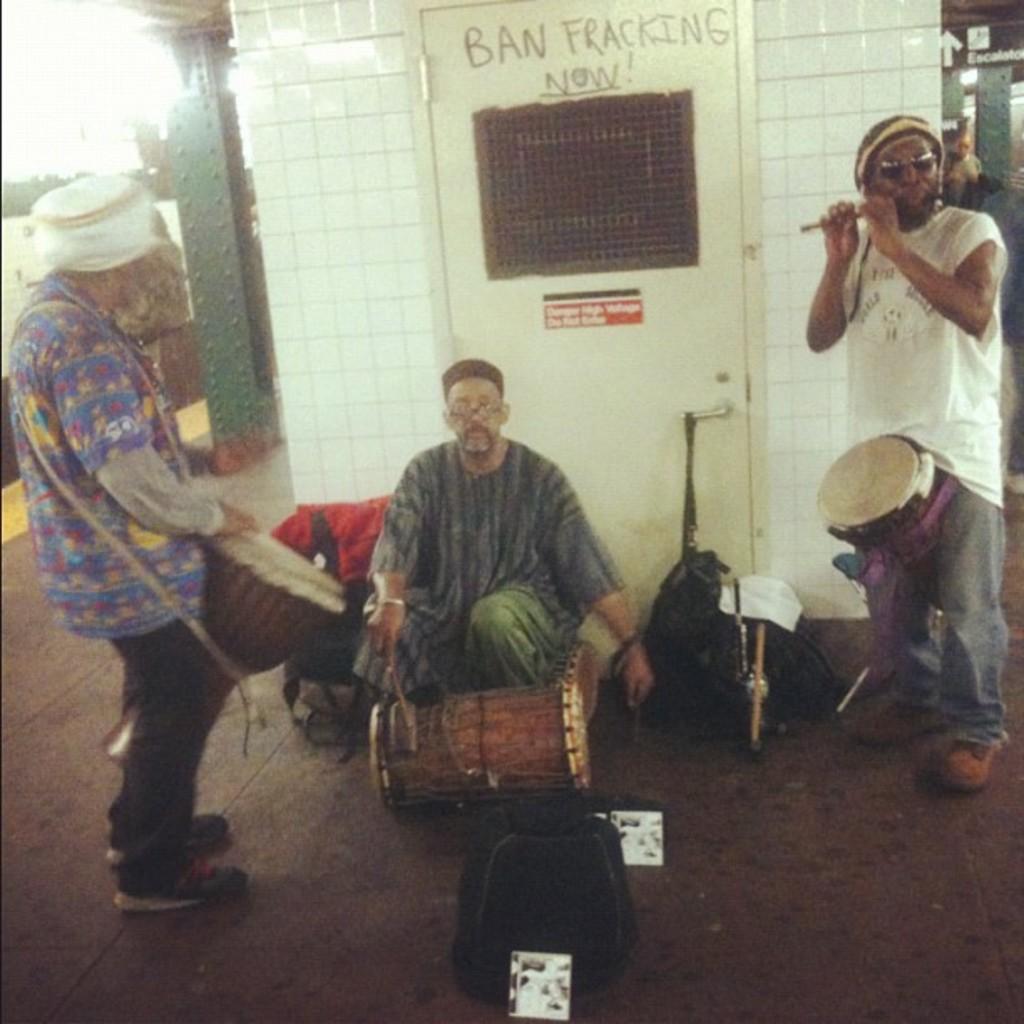Describe this image in one or two sentences. On the left side, there is a person wearing a white color cap and playing drums on the floor. Beside him, there is a person sitting and holding a stick. In front of him, there is a drum on the floor. On the right side, there is a person in white t-shirt, playing a flute on the floor, on which there are bags. In the background, there is a white wall. 